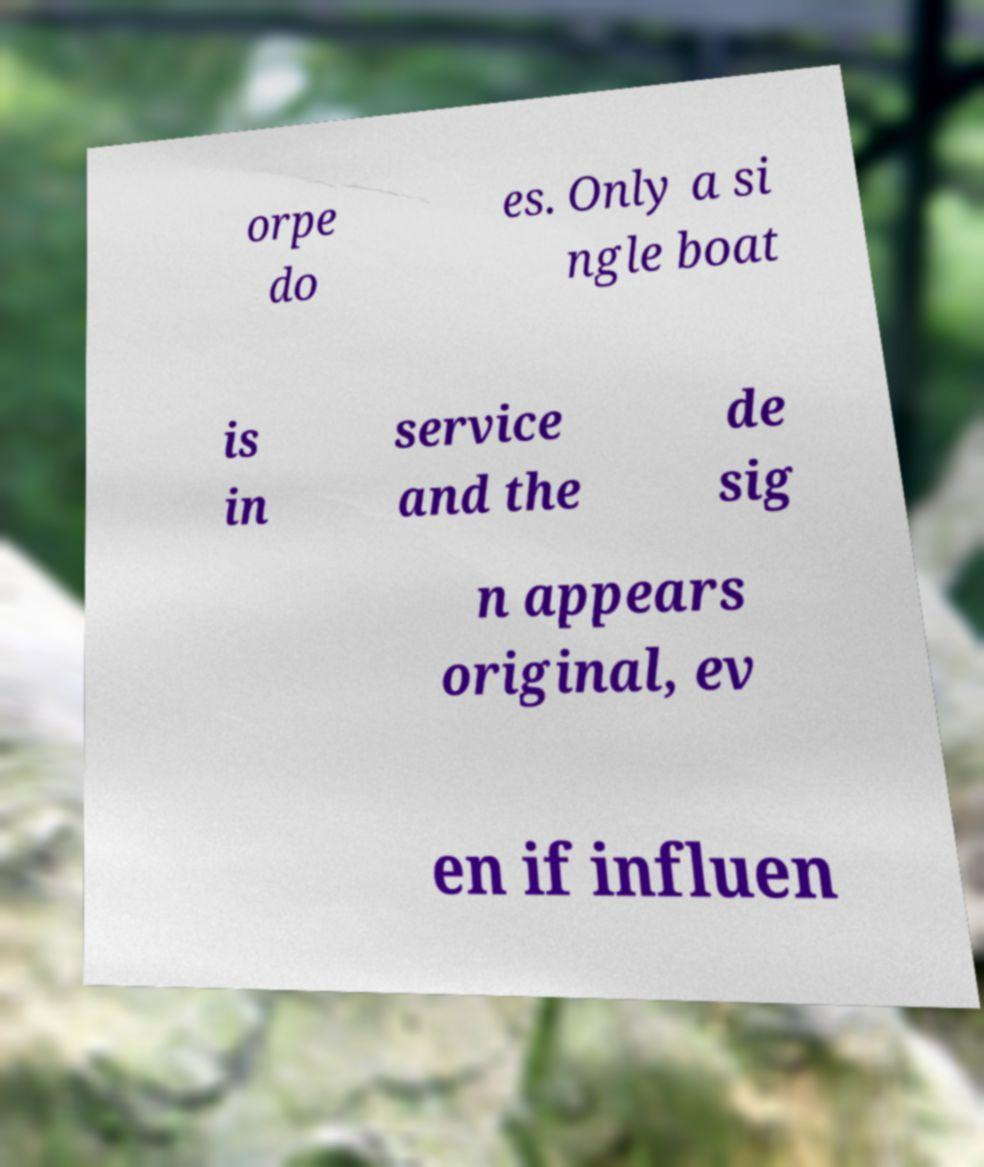For documentation purposes, I need the text within this image transcribed. Could you provide that? orpe do es. Only a si ngle boat is in service and the de sig n appears original, ev en if influen 